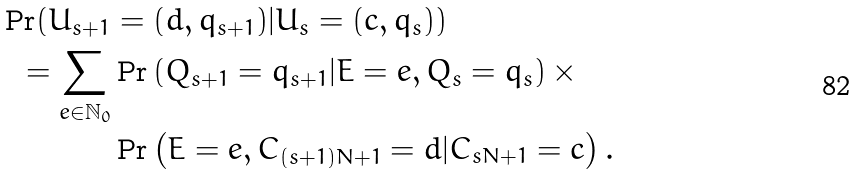Convert formula to latex. <formula><loc_0><loc_0><loc_500><loc_500>\Pr ( U _ { s + 1 } & = ( d , q _ { s + 1 } ) | U _ { s } = ( c , q _ { s } ) ) \\ = \sum _ { e \in \mathbb { N } _ { 0 } } & \Pr \left ( Q _ { s + 1 } = q _ { s + 1 } | E = e , Q _ { s } = q _ { s } \right ) \times \\ & \Pr \left ( E = e , C _ { ( s + 1 ) N + 1 } = d | C _ { s N + 1 } = c \right ) .</formula> 